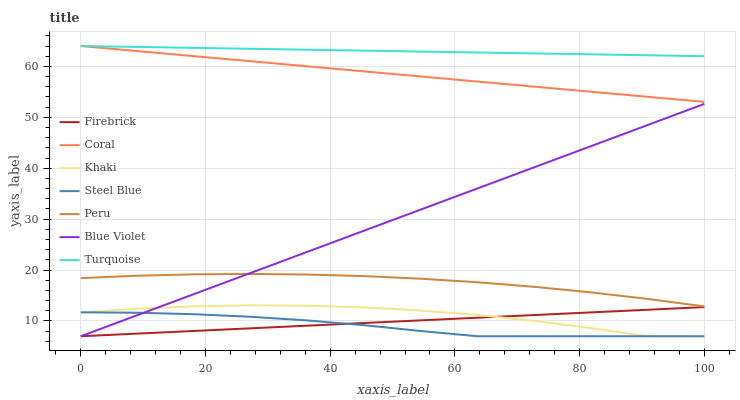Does Khaki have the minimum area under the curve?
Answer yes or no. No. Does Khaki have the maximum area under the curve?
Answer yes or no. No. Is Khaki the smoothest?
Answer yes or no. No. Is Firebrick the roughest?
Answer yes or no. No. Does Peru have the lowest value?
Answer yes or no. No. Does Khaki have the highest value?
Answer yes or no. No. Is Khaki less than Peru?
Answer yes or no. Yes. Is Turquoise greater than Steel Blue?
Answer yes or no. Yes. Does Khaki intersect Peru?
Answer yes or no. No. 